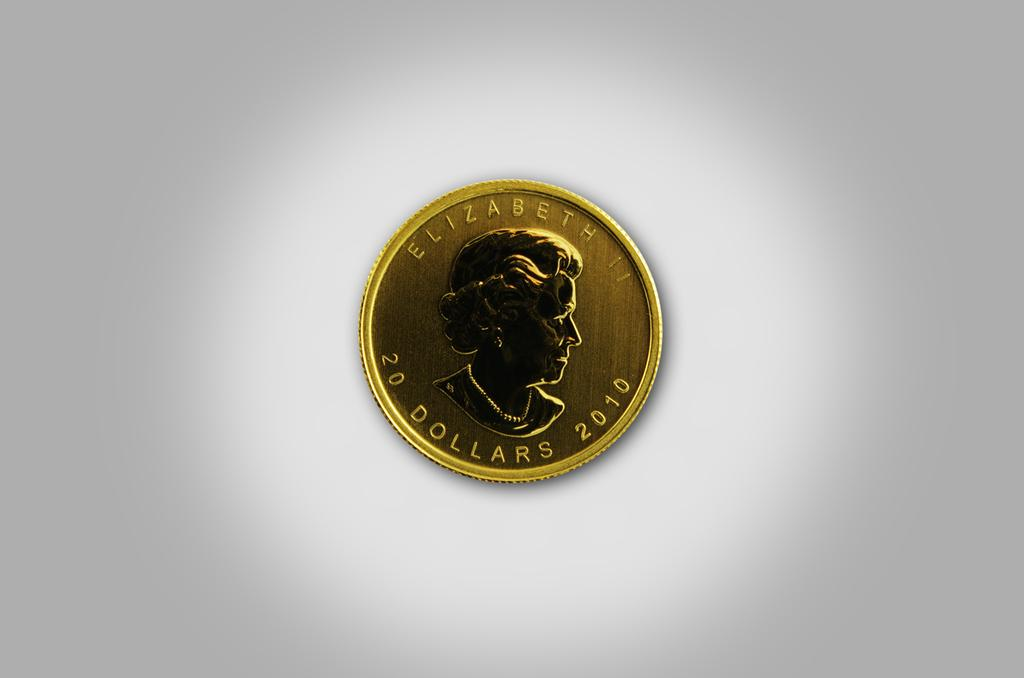<image>
Present a compact description of the photo's key features. a golden coin that says 'elizabeth 20 dollars 2010' on it 